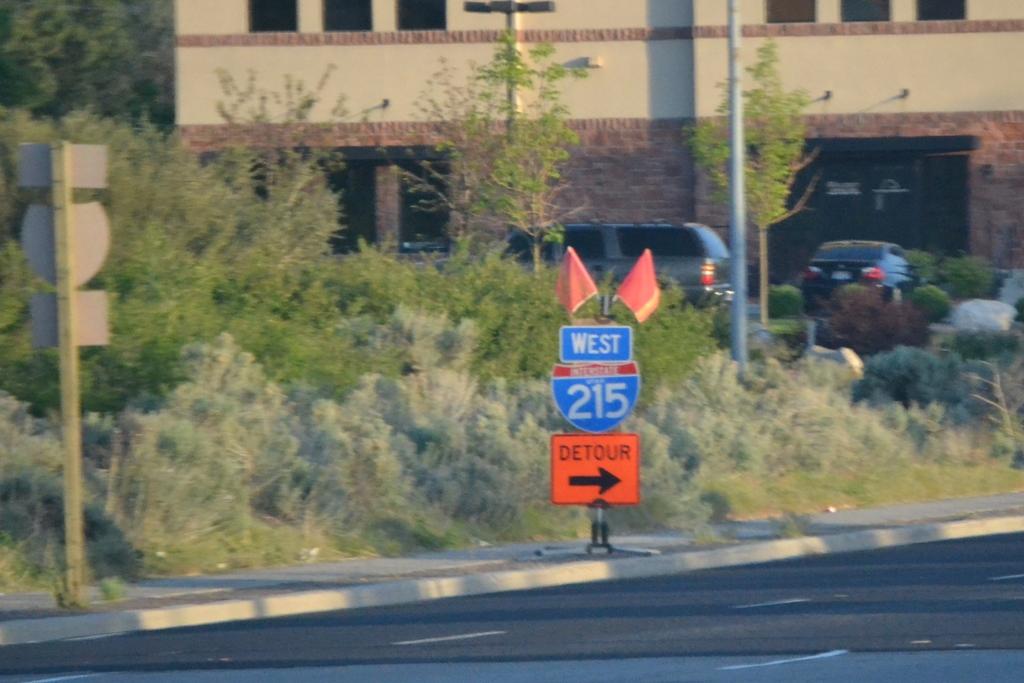What direction does the sign say?
Offer a terse response. West. What number is the highway?
Ensure brevity in your answer.  215. 